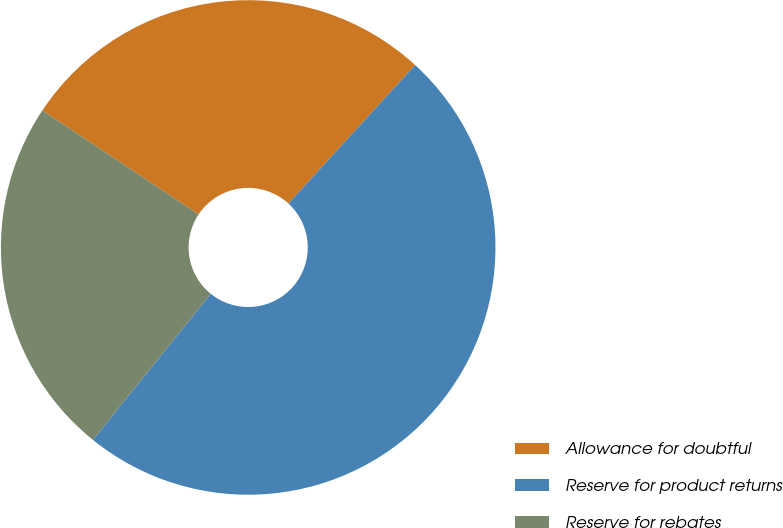<chart> <loc_0><loc_0><loc_500><loc_500><pie_chart><fcel>Allowance for doubtful<fcel>Reserve for product returns<fcel>Reserve for rebates<nl><fcel>27.45%<fcel>49.0%<fcel>23.54%<nl></chart> 